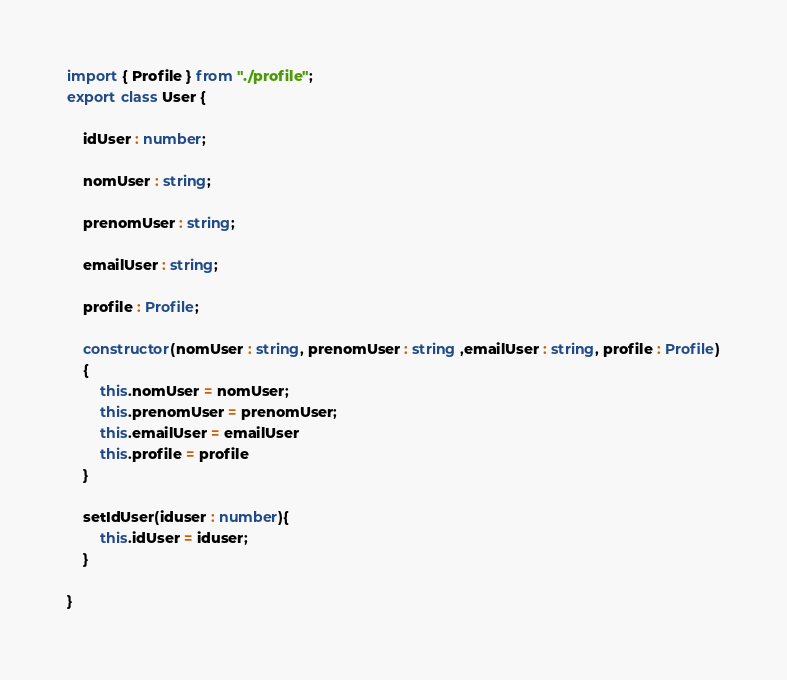<code> <loc_0><loc_0><loc_500><loc_500><_TypeScript_>import { Profile } from "./profile";
export class User {
    
    idUser : number;

    nomUser : string;

    prenomUser : string;

    emailUser : string;

    profile : Profile;

    constructor(nomUser : string, prenomUser : string ,emailUser : string, profile : Profile)
    {
        this.nomUser = nomUser;
        this.prenomUser = prenomUser;
        this.emailUser = emailUser
        this.profile = profile
    }

    setIdUser(iduser : number){
        this.idUser = iduser;
    }

}
</code> 